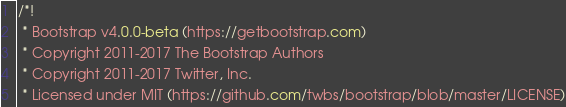<code> <loc_0><loc_0><loc_500><loc_500><_CSS_>/*!
 * Bootstrap v4.0.0-beta (https://getbootstrap.com)
 * Copyright 2011-2017 The Bootstrap Authors
 * Copyright 2011-2017 Twitter, Inc.
 * Licensed under MIT (https://github.com/twbs/bootstrap/blob/master/LICENSE)</code> 